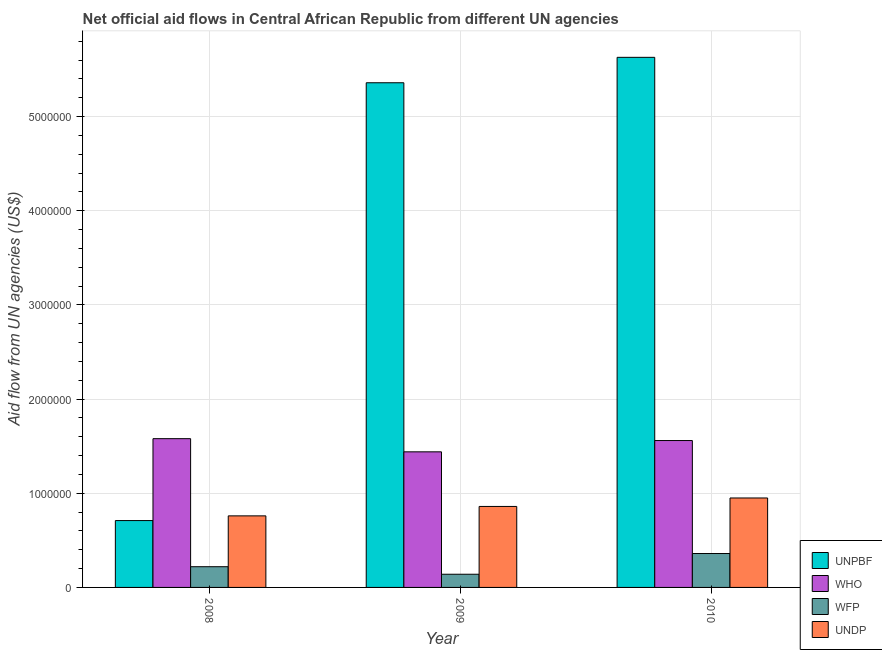How many different coloured bars are there?
Make the answer very short. 4. Are the number of bars per tick equal to the number of legend labels?
Offer a terse response. Yes. Are the number of bars on each tick of the X-axis equal?
Provide a short and direct response. Yes. How many bars are there on the 1st tick from the left?
Offer a terse response. 4. What is the amount of aid given by who in 2008?
Your answer should be compact. 1.58e+06. Across all years, what is the maximum amount of aid given by undp?
Make the answer very short. 9.50e+05. Across all years, what is the minimum amount of aid given by wfp?
Make the answer very short. 1.40e+05. In which year was the amount of aid given by wfp maximum?
Provide a succinct answer. 2010. What is the total amount of aid given by who in the graph?
Make the answer very short. 4.58e+06. What is the difference between the amount of aid given by undp in 2009 and that in 2010?
Ensure brevity in your answer.  -9.00e+04. What is the difference between the amount of aid given by unpbf in 2010 and the amount of aid given by who in 2009?
Provide a short and direct response. 2.70e+05. What is the average amount of aid given by undp per year?
Provide a succinct answer. 8.57e+05. In the year 2008, what is the difference between the amount of aid given by undp and amount of aid given by who?
Provide a short and direct response. 0. In how many years, is the amount of aid given by wfp greater than 5400000 US$?
Provide a short and direct response. 0. What is the ratio of the amount of aid given by wfp in 2009 to that in 2010?
Provide a succinct answer. 0.39. Is the amount of aid given by unpbf in 2008 less than that in 2010?
Your response must be concise. Yes. What is the difference between the highest and the lowest amount of aid given by wfp?
Make the answer very short. 2.20e+05. In how many years, is the amount of aid given by who greater than the average amount of aid given by who taken over all years?
Give a very brief answer. 2. Is the sum of the amount of aid given by unpbf in 2008 and 2009 greater than the maximum amount of aid given by who across all years?
Ensure brevity in your answer.  Yes. What does the 2nd bar from the left in 2010 represents?
Make the answer very short. WHO. What does the 3rd bar from the right in 2008 represents?
Offer a very short reply. WHO. What is the difference between two consecutive major ticks on the Y-axis?
Ensure brevity in your answer.  1.00e+06. Where does the legend appear in the graph?
Offer a very short reply. Bottom right. How many legend labels are there?
Your response must be concise. 4. How are the legend labels stacked?
Your answer should be very brief. Vertical. What is the title of the graph?
Provide a succinct answer. Net official aid flows in Central African Republic from different UN agencies. Does "UNRWA" appear as one of the legend labels in the graph?
Ensure brevity in your answer.  No. What is the label or title of the X-axis?
Provide a succinct answer. Year. What is the label or title of the Y-axis?
Make the answer very short. Aid flow from UN agencies (US$). What is the Aid flow from UN agencies (US$) in UNPBF in 2008?
Ensure brevity in your answer.  7.10e+05. What is the Aid flow from UN agencies (US$) in WHO in 2008?
Offer a very short reply. 1.58e+06. What is the Aid flow from UN agencies (US$) of WFP in 2008?
Your answer should be compact. 2.20e+05. What is the Aid flow from UN agencies (US$) in UNDP in 2008?
Make the answer very short. 7.60e+05. What is the Aid flow from UN agencies (US$) of UNPBF in 2009?
Keep it short and to the point. 5.36e+06. What is the Aid flow from UN agencies (US$) in WHO in 2009?
Provide a short and direct response. 1.44e+06. What is the Aid flow from UN agencies (US$) of WFP in 2009?
Offer a terse response. 1.40e+05. What is the Aid flow from UN agencies (US$) of UNDP in 2009?
Provide a succinct answer. 8.60e+05. What is the Aid flow from UN agencies (US$) of UNPBF in 2010?
Your answer should be compact. 5.63e+06. What is the Aid flow from UN agencies (US$) in WHO in 2010?
Keep it short and to the point. 1.56e+06. What is the Aid flow from UN agencies (US$) of UNDP in 2010?
Provide a succinct answer. 9.50e+05. Across all years, what is the maximum Aid flow from UN agencies (US$) of UNPBF?
Ensure brevity in your answer.  5.63e+06. Across all years, what is the maximum Aid flow from UN agencies (US$) of WHO?
Offer a terse response. 1.58e+06. Across all years, what is the maximum Aid flow from UN agencies (US$) in WFP?
Your response must be concise. 3.60e+05. Across all years, what is the maximum Aid flow from UN agencies (US$) of UNDP?
Offer a terse response. 9.50e+05. Across all years, what is the minimum Aid flow from UN agencies (US$) of UNPBF?
Your answer should be compact. 7.10e+05. Across all years, what is the minimum Aid flow from UN agencies (US$) in WHO?
Provide a succinct answer. 1.44e+06. Across all years, what is the minimum Aid flow from UN agencies (US$) in WFP?
Your response must be concise. 1.40e+05. Across all years, what is the minimum Aid flow from UN agencies (US$) of UNDP?
Offer a very short reply. 7.60e+05. What is the total Aid flow from UN agencies (US$) of UNPBF in the graph?
Offer a very short reply. 1.17e+07. What is the total Aid flow from UN agencies (US$) of WHO in the graph?
Offer a terse response. 4.58e+06. What is the total Aid flow from UN agencies (US$) of WFP in the graph?
Your answer should be very brief. 7.20e+05. What is the total Aid flow from UN agencies (US$) in UNDP in the graph?
Give a very brief answer. 2.57e+06. What is the difference between the Aid flow from UN agencies (US$) of UNPBF in 2008 and that in 2009?
Provide a short and direct response. -4.65e+06. What is the difference between the Aid flow from UN agencies (US$) of WHO in 2008 and that in 2009?
Give a very brief answer. 1.40e+05. What is the difference between the Aid flow from UN agencies (US$) in UNPBF in 2008 and that in 2010?
Your answer should be compact. -4.92e+06. What is the difference between the Aid flow from UN agencies (US$) in WHO in 2008 and that in 2010?
Your answer should be very brief. 2.00e+04. What is the difference between the Aid flow from UN agencies (US$) in WFP in 2008 and that in 2010?
Keep it short and to the point. -1.40e+05. What is the difference between the Aid flow from UN agencies (US$) of UNDP in 2009 and that in 2010?
Your answer should be compact. -9.00e+04. What is the difference between the Aid flow from UN agencies (US$) in UNPBF in 2008 and the Aid flow from UN agencies (US$) in WHO in 2009?
Your answer should be compact. -7.30e+05. What is the difference between the Aid flow from UN agencies (US$) of UNPBF in 2008 and the Aid flow from UN agencies (US$) of WFP in 2009?
Your answer should be very brief. 5.70e+05. What is the difference between the Aid flow from UN agencies (US$) in UNPBF in 2008 and the Aid flow from UN agencies (US$) in UNDP in 2009?
Your answer should be very brief. -1.50e+05. What is the difference between the Aid flow from UN agencies (US$) in WHO in 2008 and the Aid flow from UN agencies (US$) in WFP in 2009?
Provide a short and direct response. 1.44e+06. What is the difference between the Aid flow from UN agencies (US$) in WHO in 2008 and the Aid flow from UN agencies (US$) in UNDP in 2009?
Offer a very short reply. 7.20e+05. What is the difference between the Aid flow from UN agencies (US$) of WFP in 2008 and the Aid flow from UN agencies (US$) of UNDP in 2009?
Ensure brevity in your answer.  -6.40e+05. What is the difference between the Aid flow from UN agencies (US$) of UNPBF in 2008 and the Aid flow from UN agencies (US$) of WHO in 2010?
Provide a short and direct response. -8.50e+05. What is the difference between the Aid flow from UN agencies (US$) in WHO in 2008 and the Aid flow from UN agencies (US$) in WFP in 2010?
Give a very brief answer. 1.22e+06. What is the difference between the Aid flow from UN agencies (US$) of WHO in 2008 and the Aid flow from UN agencies (US$) of UNDP in 2010?
Keep it short and to the point. 6.30e+05. What is the difference between the Aid flow from UN agencies (US$) in WFP in 2008 and the Aid flow from UN agencies (US$) in UNDP in 2010?
Provide a succinct answer. -7.30e+05. What is the difference between the Aid flow from UN agencies (US$) of UNPBF in 2009 and the Aid flow from UN agencies (US$) of WHO in 2010?
Provide a succinct answer. 3.80e+06. What is the difference between the Aid flow from UN agencies (US$) of UNPBF in 2009 and the Aid flow from UN agencies (US$) of WFP in 2010?
Provide a short and direct response. 5.00e+06. What is the difference between the Aid flow from UN agencies (US$) of UNPBF in 2009 and the Aid flow from UN agencies (US$) of UNDP in 2010?
Offer a very short reply. 4.41e+06. What is the difference between the Aid flow from UN agencies (US$) in WHO in 2009 and the Aid flow from UN agencies (US$) in WFP in 2010?
Provide a succinct answer. 1.08e+06. What is the difference between the Aid flow from UN agencies (US$) of WHO in 2009 and the Aid flow from UN agencies (US$) of UNDP in 2010?
Ensure brevity in your answer.  4.90e+05. What is the difference between the Aid flow from UN agencies (US$) of WFP in 2009 and the Aid flow from UN agencies (US$) of UNDP in 2010?
Keep it short and to the point. -8.10e+05. What is the average Aid flow from UN agencies (US$) in UNPBF per year?
Your answer should be very brief. 3.90e+06. What is the average Aid flow from UN agencies (US$) of WHO per year?
Ensure brevity in your answer.  1.53e+06. What is the average Aid flow from UN agencies (US$) of UNDP per year?
Provide a succinct answer. 8.57e+05. In the year 2008, what is the difference between the Aid flow from UN agencies (US$) in UNPBF and Aid flow from UN agencies (US$) in WHO?
Make the answer very short. -8.70e+05. In the year 2008, what is the difference between the Aid flow from UN agencies (US$) of UNPBF and Aid flow from UN agencies (US$) of WFP?
Keep it short and to the point. 4.90e+05. In the year 2008, what is the difference between the Aid flow from UN agencies (US$) in UNPBF and Aid flow from UN agencies (US$) in UNDP?
Make the answer very short. -5.00e+04. In the year 2008, what is the difference between the Aid flow from UN agencies (US$) in WHO and Aid flow from UN agencies (US$) in WFP?
Keep it short and to the point. 1.36e+06. In the year 2008, what is the difference between the Aid flow from UN agencies (US$) of WHO and Aid flow from UN agencies (US$) of UNDP?
Ensure brevity in your answer.  8.20e+05. In the year 2008, what is the difference between the Aid flow from UN agencies (US$) of WFP and Aid flow from UN agencies (US$) of UNDP?
Your answer should be very brief. -5.40e+05. In the year 2009, what is the difference between the Aid flow from UN agencies (US$) in UNPBF and Aid flow from UN agencies (US$) in WHO?
Make the answer very short. 3.92e+06. In the year 2009, what is the difference between the Aid flow from UN agencies (US$) of UNPBF and Aid flow from UN agencies (US$) of WFP?
Your response must be concise. 5.22e+06. In the year 2009, what is the difference between the Aid flow from UN agencies (US$) in UNPBF and Aid flow from UN agencies (US$) in UNDP?
Ensure brevity in your answer.  4.50e+06. In the year 2009, what is the difference between the Aid flow from UN agencies (US$) in WHO and Aid flow from UN agencies (US$) in WFP?
Make the answer very short. 1.30e+06. In the year 2009, what is the difference between the Aid flow from UN agencies (US$) in WHO and Aid flow from UN agencies (US$) in UNDP?
Offer a very short reply. 5.80e+05. In the year 2009, what is the difference between the Aid flow from UN agencies (US$) of WFP and Aid flow from UN agencies (US$) of UNDP?
Offer a terse response. -7.20e+05. In the year 2010, what is the difference between the Aid flow from UN agencies (US$) in UNPBF and Aid flow from UN agencies (US$) in WHO?
Offer a terse response. 4.07e+06. In the year 2010, what is the difference between the Aid flow from UN agencies (US$) in UNPBF and Aid flow from UN agencies (US$) in WFP?
Offer a very short reply. 5.27e+06. In the year 2010, what is the difference between the Aid flow from UN agencies (US$) in UNPBF and Aid flow from UN agencies (US$) in UNDP?
Keep it short and to the point. 4.68e+06. In the year 2010, what is the difference between the Aid flow from UN agencies (US$) in WHO and Aid flow from UN agencies (US$) in WFP?
Provide a short and direct response. 1.20e+06. In the year 2010, what is the difference between the Aid flow from UN agencies (US$) of WFP and Aid flow from UN agencies (US$) of UNDP?
Your answer should be compact. -5.90e+05. What is the ratio of the Aid flow from UN agencies (US$) of UNPBF in 2008 to that in 2009?
Ensure brevity in your answer.  0.13. What is the ratio of the Aid flow from UN agencies (US$) in WHO in 2008 to that in 2009?
Ensure brevity in your answer.  1.1. What is the ratio of the Aid flow from UN agencies (US$) of WFP in 2008 to that in 2009?
Your answer should be compact. 1.57. What is the ratio of the Aid flow from UN agencies (US$) in UNDP in 2008 to that in 2009?
Your response must be concise. 0.88. What is the ratio of the Aid flow from UN agencies (US$) of UNPBF in 2008 to that in 2010?
Give a very brief answer. 0.13. What is the ratio of the Aid flow from UN agencies (US$) of WHO in 2008 to that in 2010?
Ensure brevity in your answer.  1.01. What is the ratio of the Aid flow from UN agencies (US$) in WFP in 2008 to that in 2010?
Ensure brevity in your answer.  0.61. What is the ratio of the Aid flow from UN agencies (US$) in UNDP in 2008 to that in 2010?
Offer a terse response. 0.8. What is the ratio of the Aid flow from UN agencies (US$) of WFP in 2009 to that in 2010?
Provide a short and direct response. 0.39. What is the ratio of the Aid flow from UN agencies (US$) in UNDP in 2009 to that in 2010?
Your answer should be very brief. 0.91. What is the difference between the highest and the second highest Aid flow from UN agencies (US$) in UNDP?
Your answer should be very brief. 9.00e+04. What is the difference between the highest and the lowest Aid flow from UN agencies (US$) in UNPBF?
Your answer should be compact. 4.92e+06. What is the difference between the highest and the lowest Aid flow from UN agencies (US$) of WHO?
Ensure brevity in your answer.  1.40e+05. 